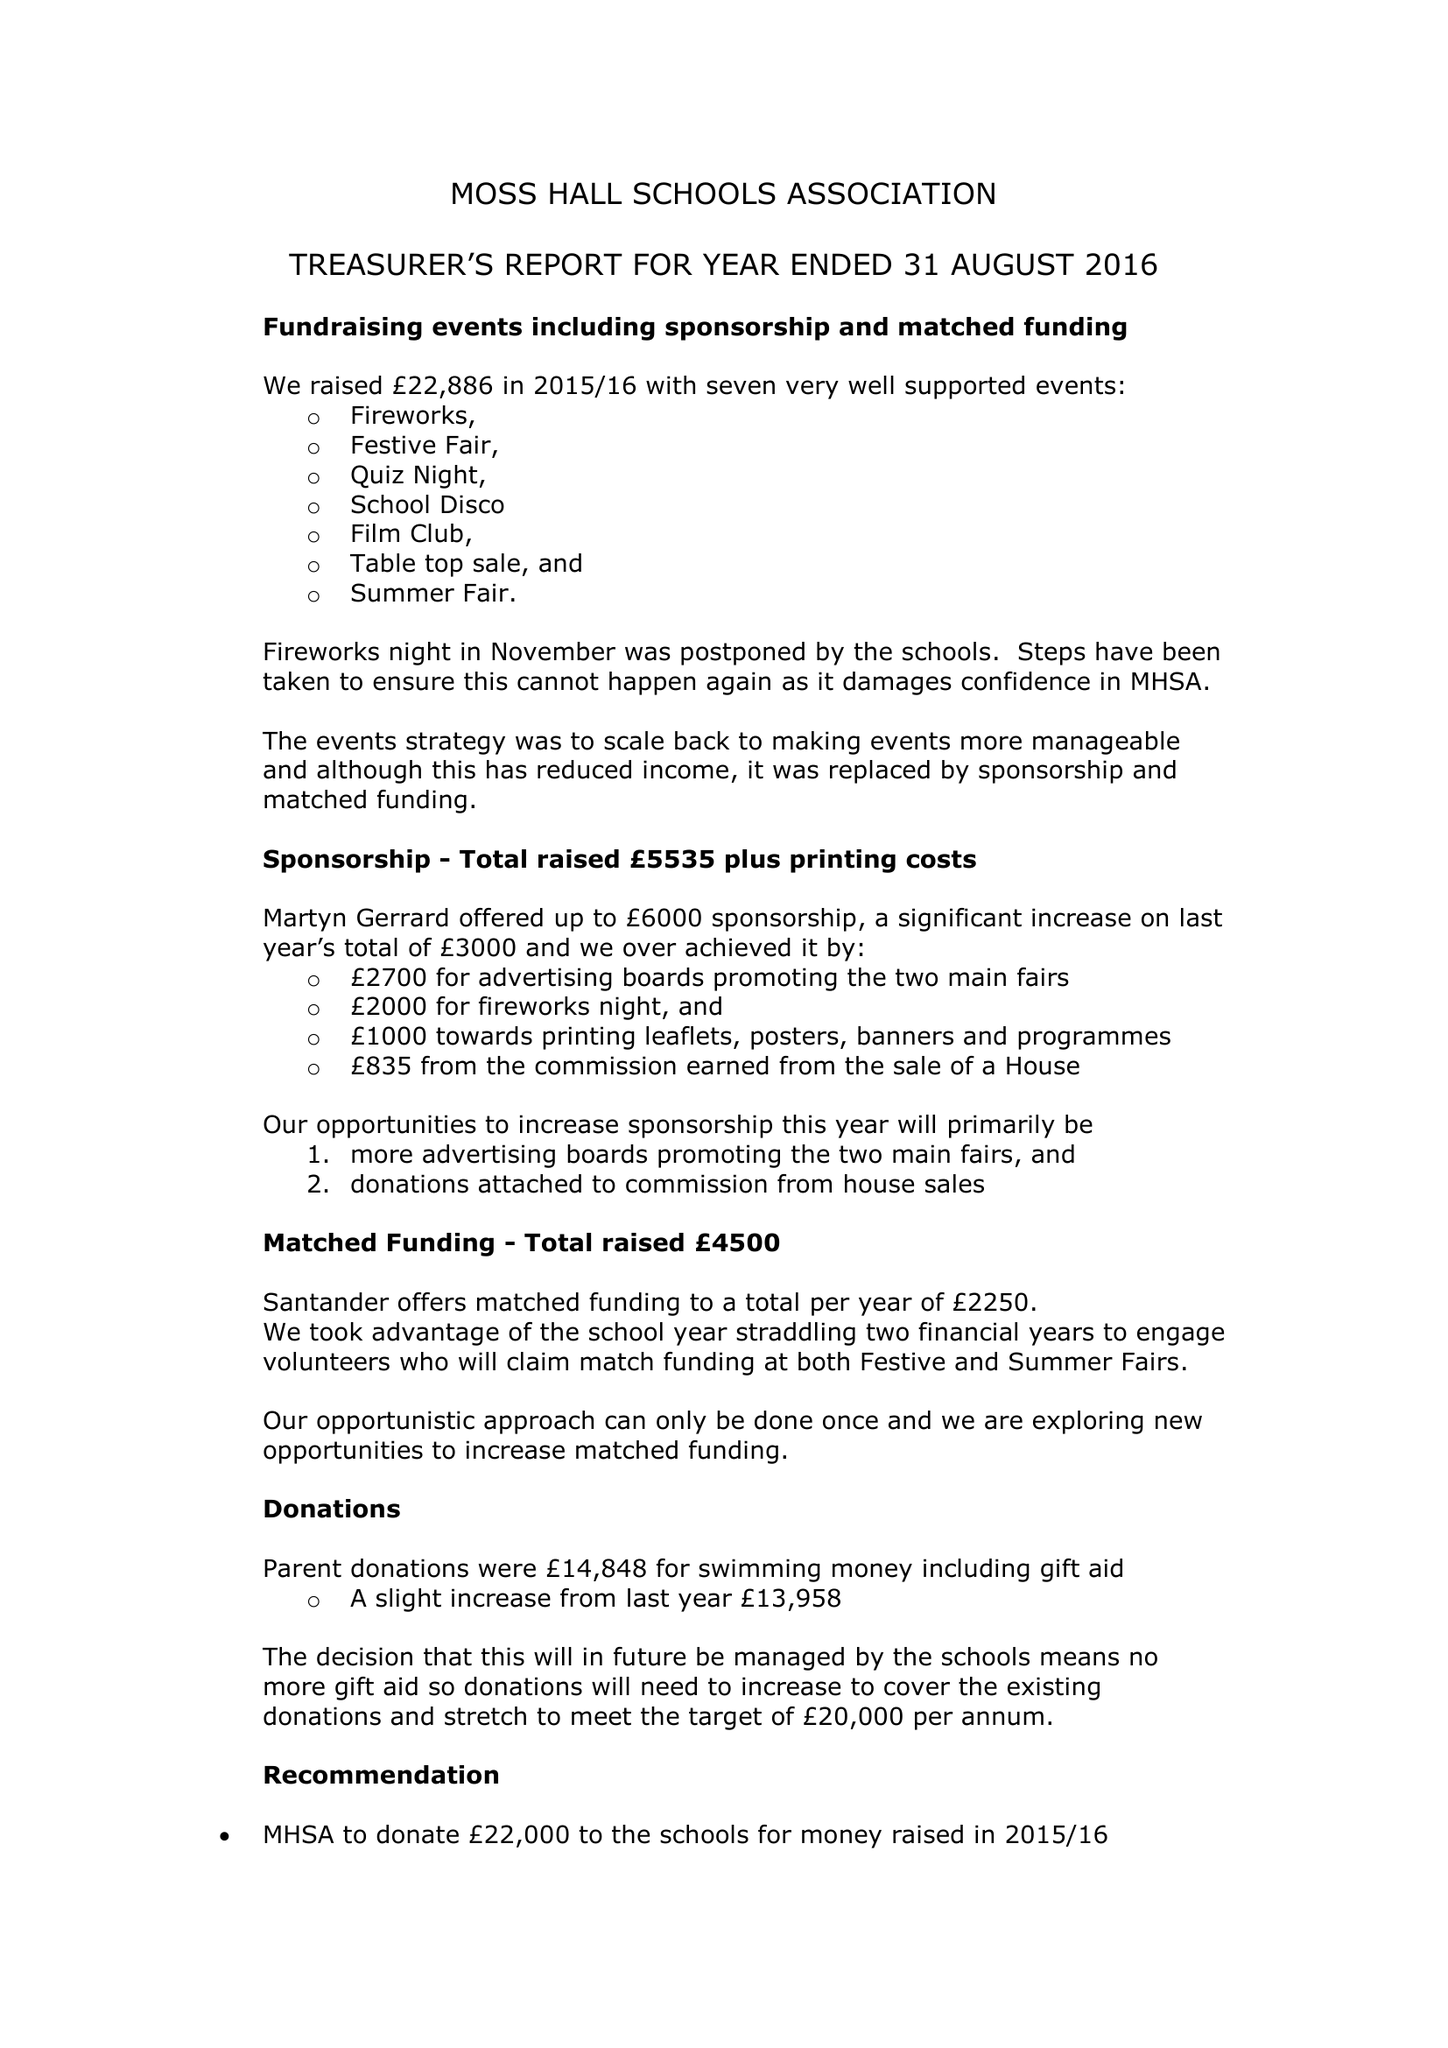What is the value for the charity_number?
Answer the question using a single word or phrase. 278150 